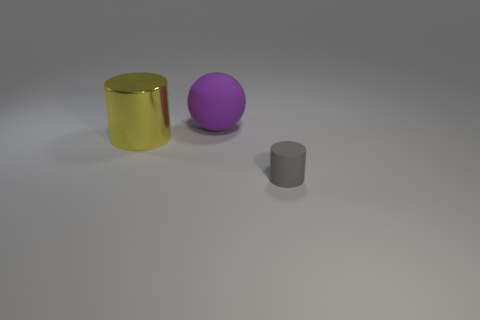Subtract all yellow cylinders. How many cylinders are left? 1 Add 3 large matte things. How many objects exist? 6 Subtract all cylinders. How many objects are left? 1 Subtract 2 cylinders. How many cylinders are left? 0 Subtract all green cubes. How many gray cylinders are left? 1 Subtract all blue matte blocks. Subtract all big balls. How many objects are left? 2 Add 2 shiny things. How many shiny things are left? 3 Add 3 big purple matte spheres. How many big purple matte spheres exist? 4 Subtract 0 brown cubes. How many objects are left? 3 Subtract all green spheres. Subtract all cyan blocks. How many spheres are left? 1 